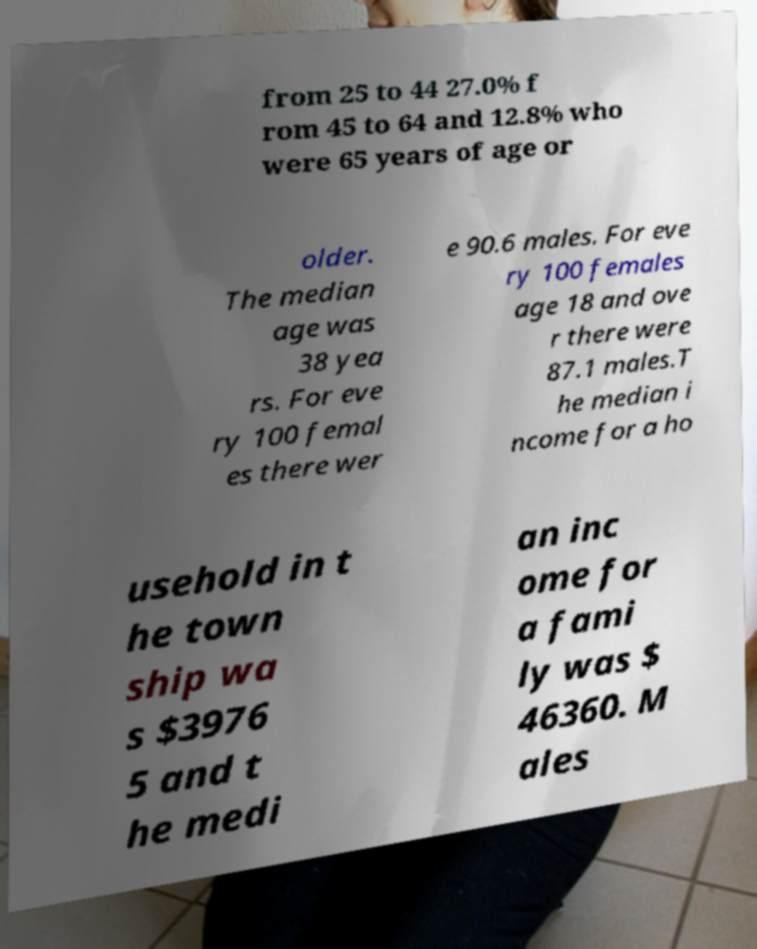Can you accurately transcribe the text from the provided image for me? from 25 to 44 27.0% f rom 45 to 64 and 12.8% who were 65 years of age or older. The median age was 38 yea rs. For eve ry 100 femal es there wer e 90.6 males. For eve ry 100 females age 18 and ove r there were 87.1 males.T he median i ncome for a ho usehold in t he town ship wa s $3976 5 and t he medi an inc ome for a fami ly was $ 46360. M ales 